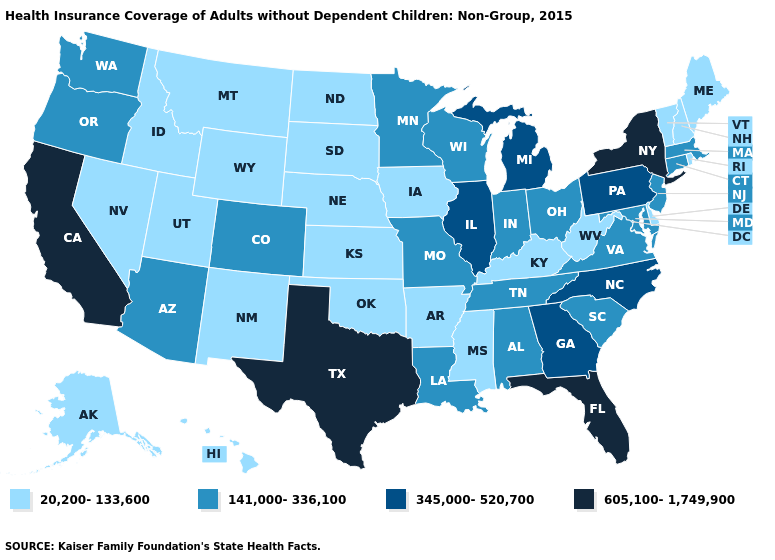What is the value of Michigan?
Give a very brief answer. 345,000-520,700. Does Washington have the lowest value in the USA?
Quick response, please. No. What is the highest value in the West ?
Concise answer only. 605,100-1,749,900. Among the states that border California , which have the lowest value?
Concise answer only. Nevada. How many symbols are there in the legend?
Concise answer only. 4. Which states have the lowest value in the USA?
Answer briefly. Alaska, Arkansas, Delaware, Hawaii, Idaho, Iowa, Kansas, Kentucky, Maine, Mississippi, Montana, Nebraska, Nevada, New Hampshire, New Mexico, North Dakota, Oklahoma, Rhode Island, South Dakota, Utah, Vermont, West Virginia, Wyoming. What is the lowest value in the South?
Write a very short answer. 20,200-133,600. What is the value of Utah?
Write a very short answer. 20,200-133,600. How many symbols are there in the legend?
Short answer required. 4. What is the lowest value in the USA?
Answer briefly. 20,200-133,600. Among the states that border Arizona , does Colorado have the lowest value?
Quick response, please. No. What is the value of Virginia?
Keep it brief. 141,000-336,100. What is the value of Tennessee?
Quick response, please. 141,000-336,100. Name the states that have a value in the range 20,200-133,600?
Short answer required. Alaska, Arkansas, Delaware, Hawaii, Idaho, Iowa, Kansas, Kentucky, Maine, Mississippi, Montana, Nebraska, Nevada, New Hampshire, New Mexico, North Dakota, Oklahoma, Rhode Island, South Dakota, Utah, Vermont, West Virginia, Wyoming. Name the states that have a value in the range 141,000-336,100?
Quick response, please. Alabama, Arizona, Colorado, Connecticut, Indiana, Louisiana, Maryland, Massachusetts, Minnesota, Missouri, New Jersey, Ohio, Oregon, South Carolina, Tennessee, Virginia, Washington, Wisconsin. 